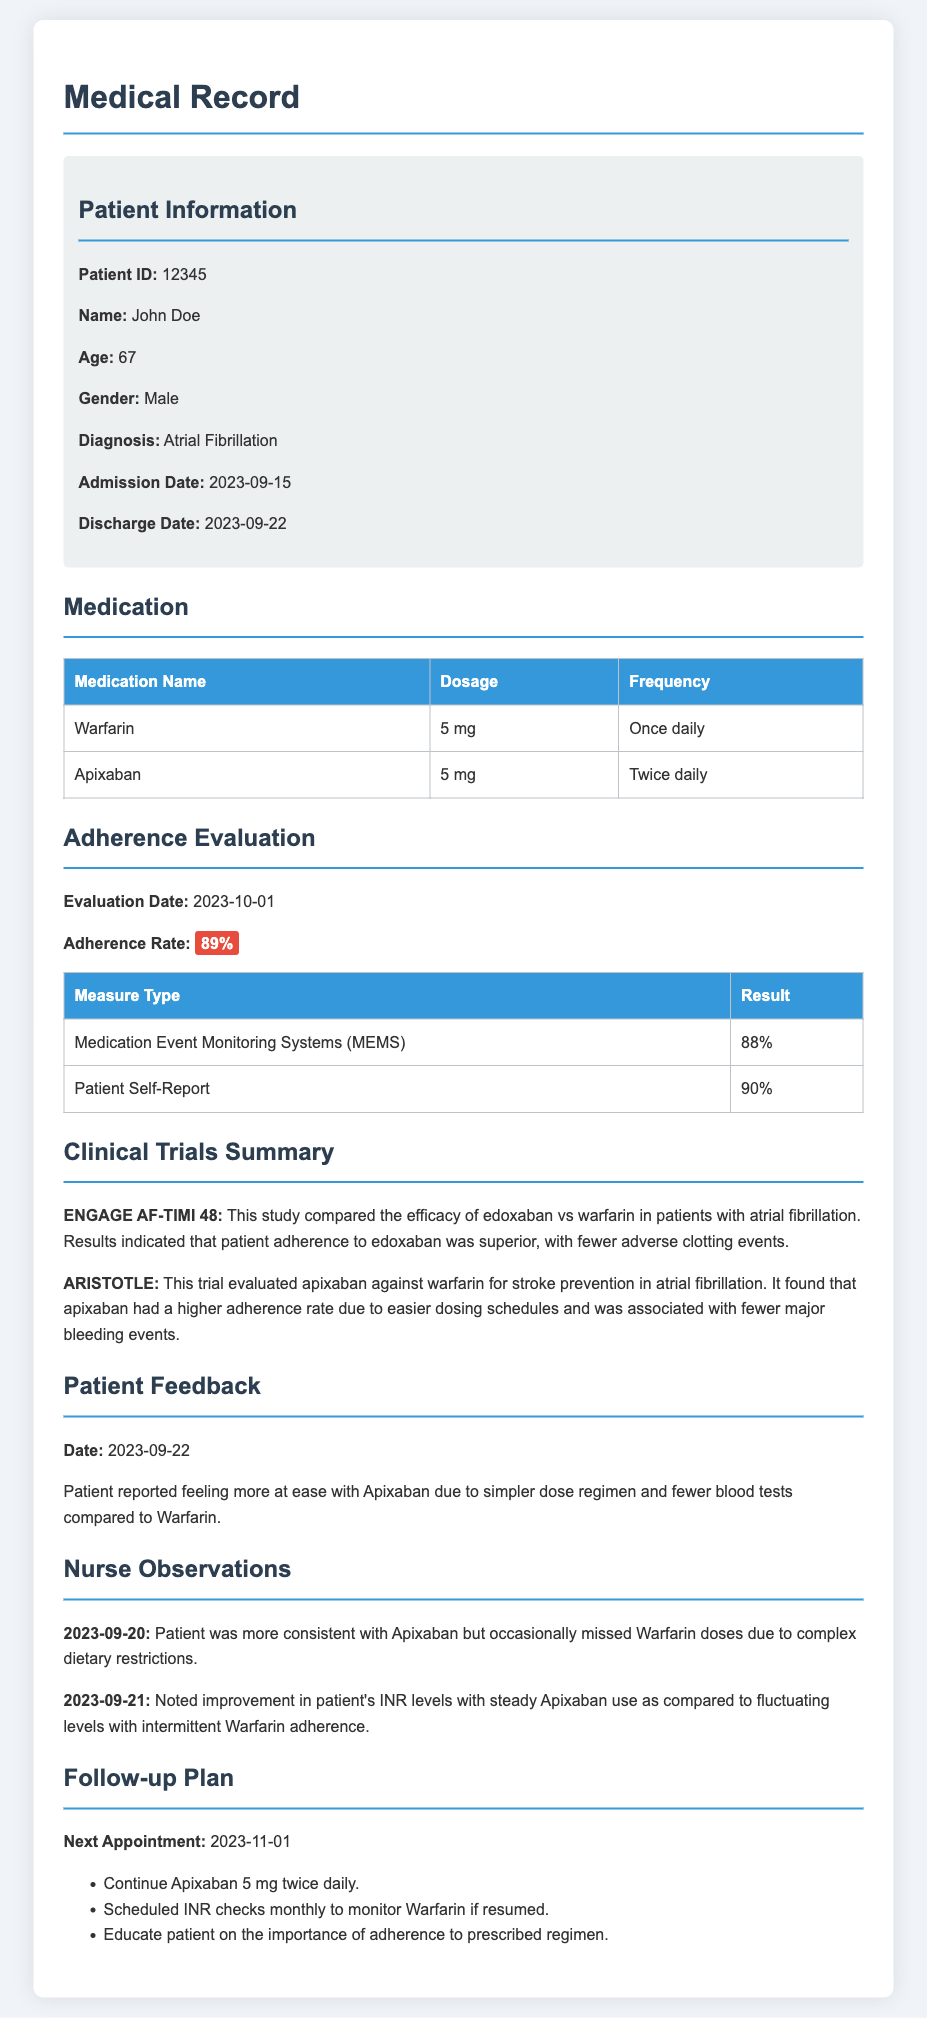What is the patient's name? The document states the patient's name as John Doe.
Answer: John Doe What is the diagnosis? The diagnosis for the patient mentioned in the document is Atrial Fibrillation.
Answer: Atrial Fibrillation What is the adherence rate? The adherence rate as per the evaluation date is highlighted as 89%.
Answer: 89% What medications is the patient taking? The medications listed for the patient are Warfarin and Apixaban.
Answer: Warfarin, Apixaban What date is the next appointment? The document indicates that the next appointment is scheduled for 2023-11-01.
Answer: 2023-11-01 Which clinical trial showed higher patient adherence to apixaban? The trial ARISTOTLE found a higher adherence rate for apixaban due to easier dosing schedules.
Answer: ARISTOTLE What was the patient's feedback regarding Apixaban? The patient reported feeling more at ease with Apixaban due to a simpler dose regimen.
Answer: Simpler dose regimen On what date was the adherence evaluation conducted? The adherence evaluation was conducted on 2023-10-01.
Answer: 2023-10-01 What was noted on 2023-09-21 regarding INR levels? An improvement in the patient's INR levels was noted with steady Apixaban use.
Answer: Improvement in INR levels 